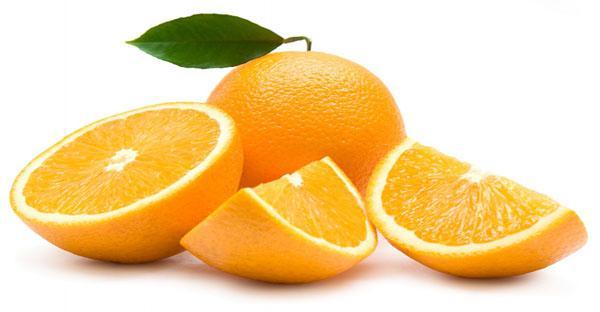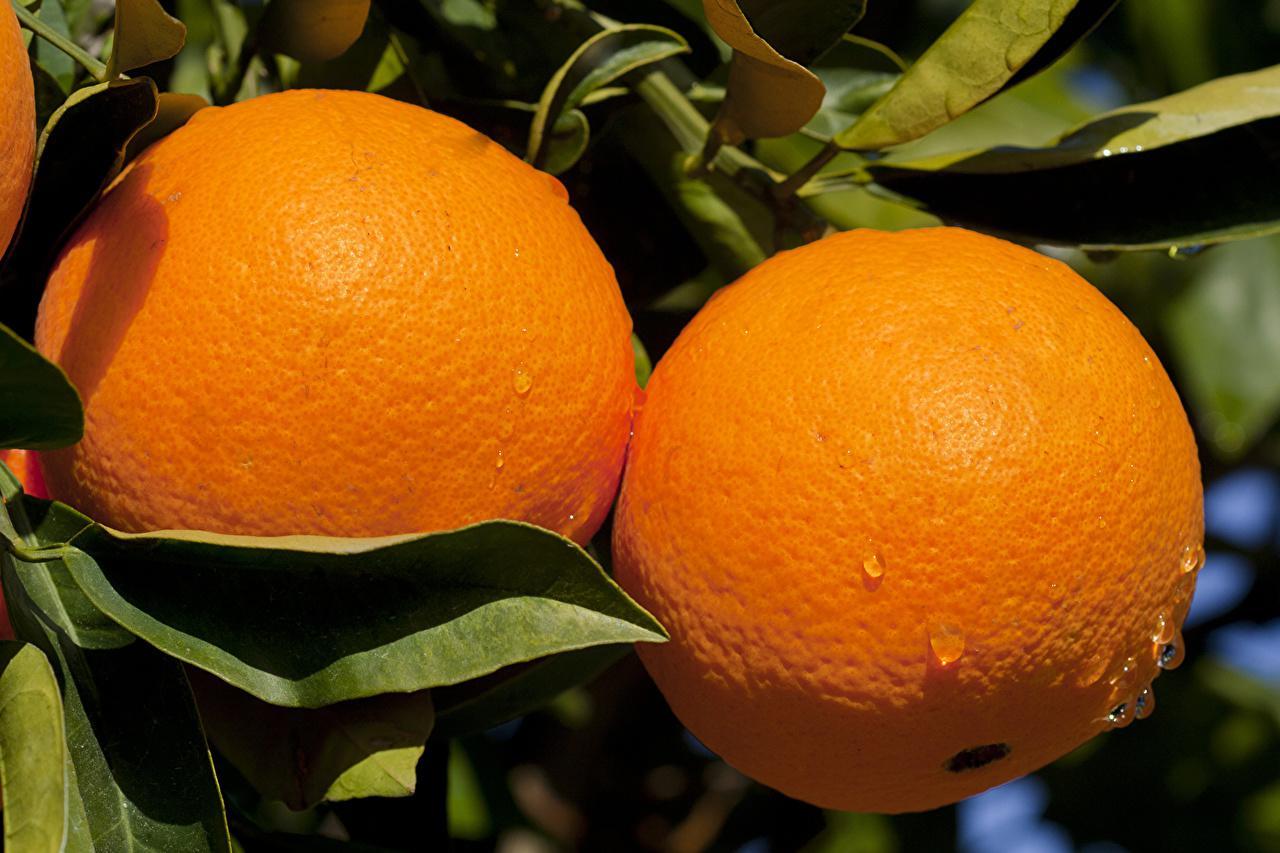The first image is the image on the left, the second image is the image on the right. Evaluate the accuracy of this statement regarding the images: "In total, the images contain the equivalent of four oranges.". Is it true? Answer yes or no. Yes. The first image is the image on the left, the second image is the image on the right. Assess this claim about the two images: "There are four uncut oranges.". Correct or not? Answer yes or no. No. 